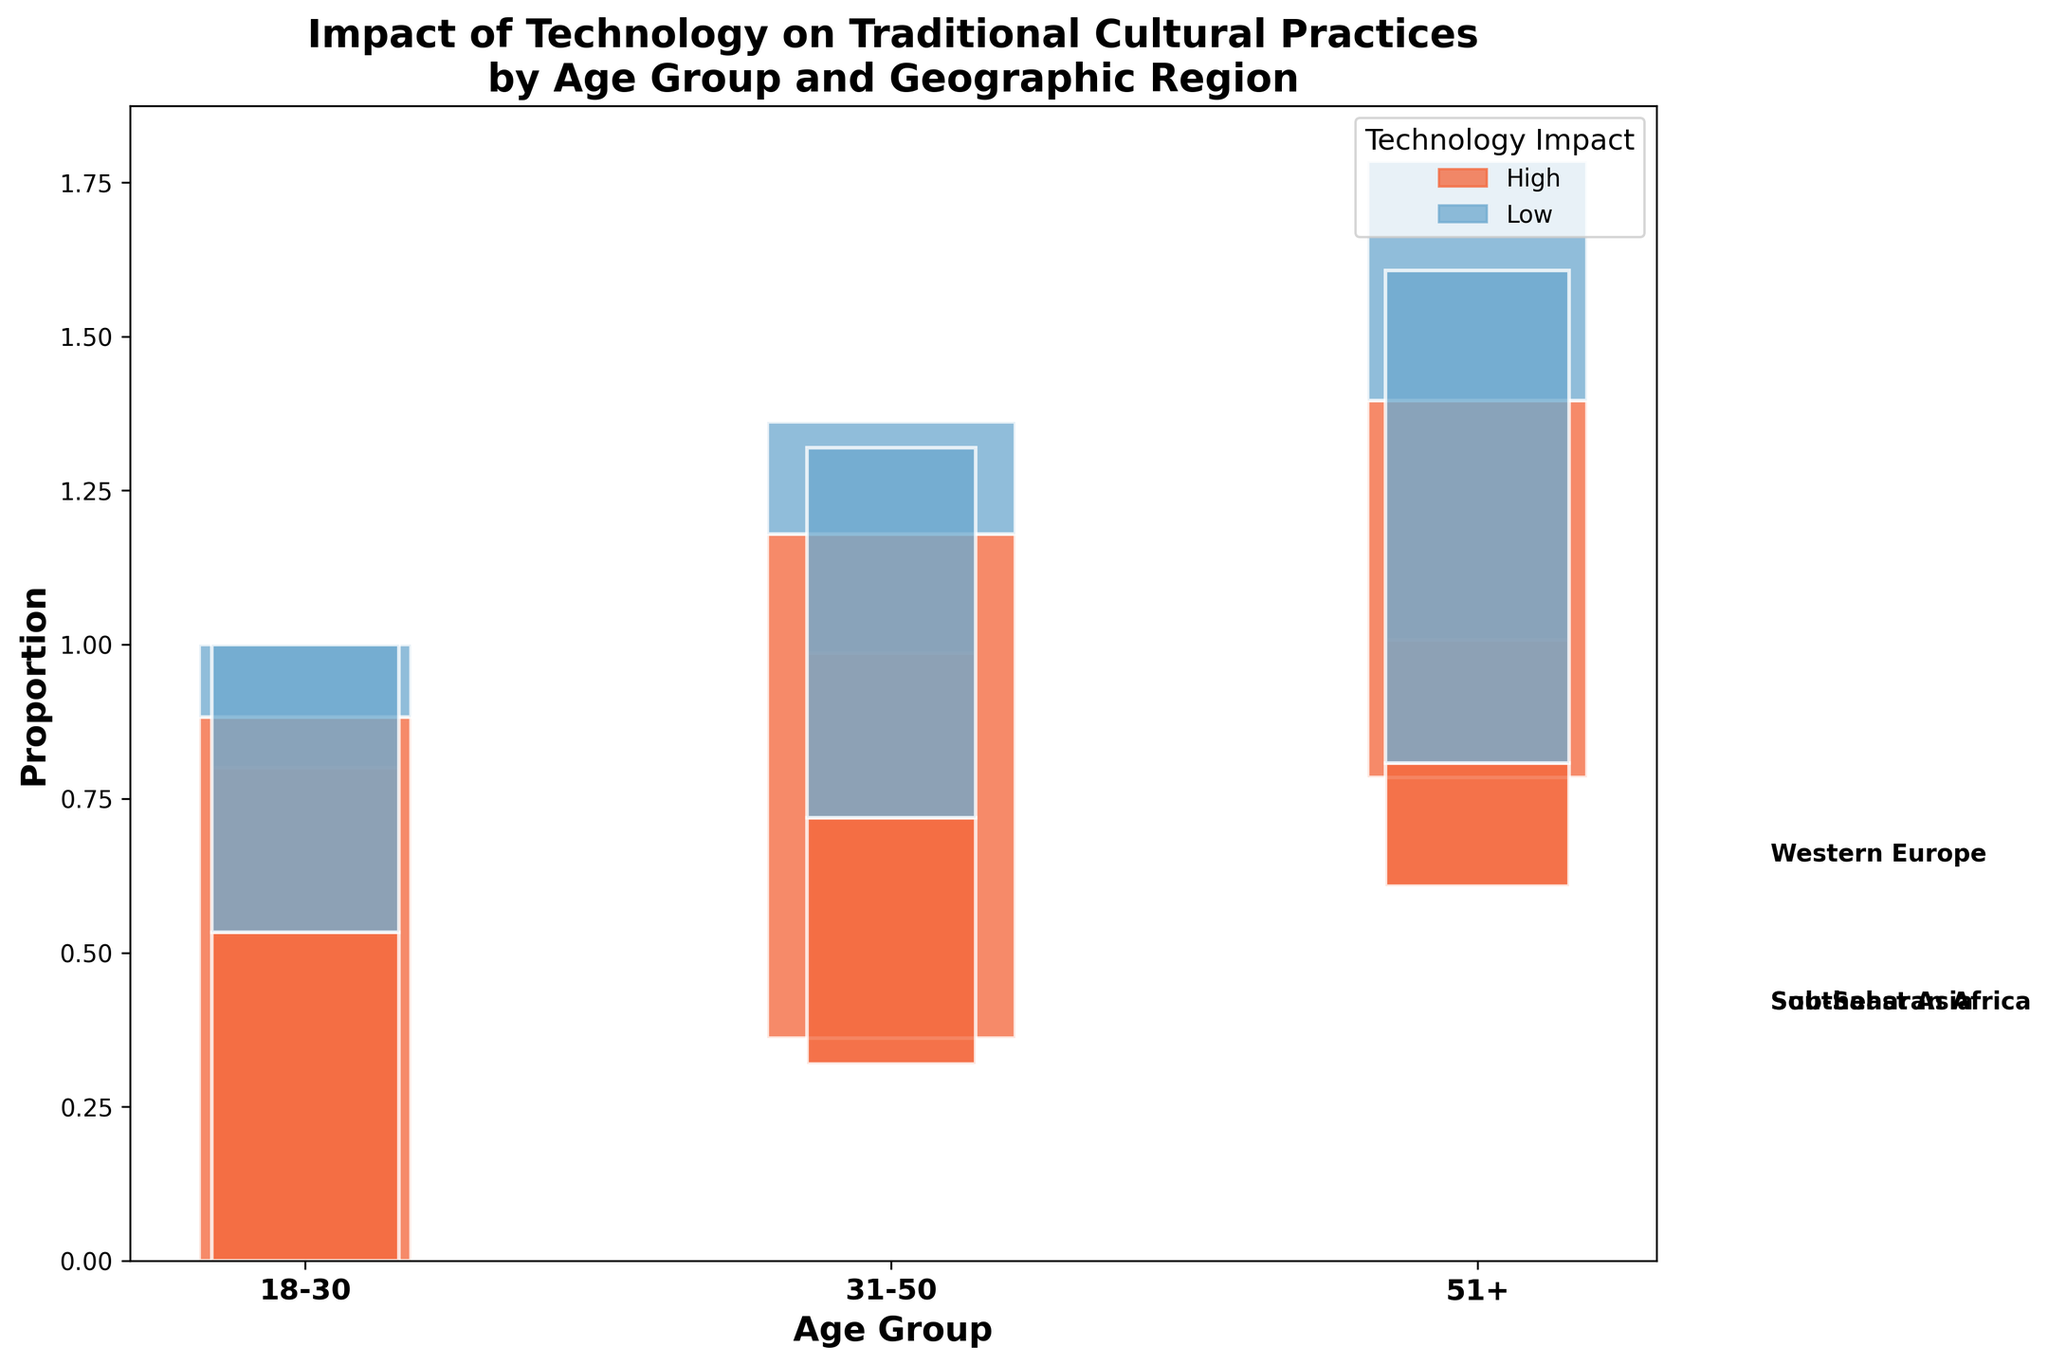What is the title of the figure? The title is usually found at the top of the figure, indicating the main subject of the visualization.
Answer: Impact of Technology on Traditional Cultural Practices by Age Group and Geographic Region What do the colors in the plot represent? The legend on the right side of the figure indicates that there are two different colors, each representing a different level of technology impact: High and Low.
Answer: High and Low levels of technology impact Which age group in Western Europe has the highest proportion of high technology impact? By examining the bars for Western Europe, identify the one with the largest proportion of the color associated with high technology impact within the age groups (18-30, 31-50, 51+).
Answer: 31-50 How does the proportion of high technology impact change as age increases for Southeast Asia? By analyzing the bars corresponding to Southeast Asia across different age groups, observe the portion of the bars filled with the color representing high technology impact; it decreases as age increases.
Answer: It decreases Compare the proportion of low technology impact between the 18-30 and 51+ age groups in Sub-Saharan Africa. Which has a higher proportion? Examine the bars for Sub-Saharan Africa and note the proportion of the color representing low technology impact for both age groups. 51+ has a larger part of the bar in the color representing low technology impact.
Answer: 51+ Which geographic region shows the smallest difference in high technology impact proportions between the youngest and oldest age groups? Look at the segments representing high technology impact across regions and compare the differences in proportions between the 18-30 and 51+ age groups; Western Europe has the least difference.
Answer: Western Europe What is the geographic region with the lowest overall high technology impact across all age groups? By comparing the cumulative proportions of high technology impact across all age groups in each region, note the smallest overall proportion; Sub-Saharan Africa has the lowest.
Answer: Sub-Saharan Africa For the 31-50 age group, which region shows a higher proportion of low technology impact? Within the 31-50 age group, compare the proportions of the color representing low technology impact across the different regions; Sub-Saharan Africa has the higher proportion.
Answer: Sub-Saharan Africa 